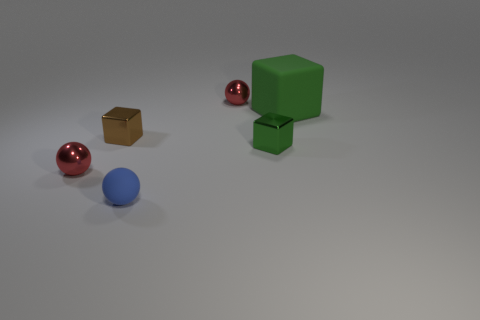Subtract all brown cubes. How many red balls are left? 2 Subtract 1 balls. How many balls are left? 2 Add 4 large gray rubber cylinders. How many objects exist? 10 Add 1 tiny shiny cubes. How many tiny shiny cubes exist? 3 Subtract 0 green balls. How many objects are left? 6 Subtract all small brown metallic objects. Subtract all tiny matte objects. How many objects are left? 4 Add 6 big green rubber things. How many big green rubber things are left? 7 